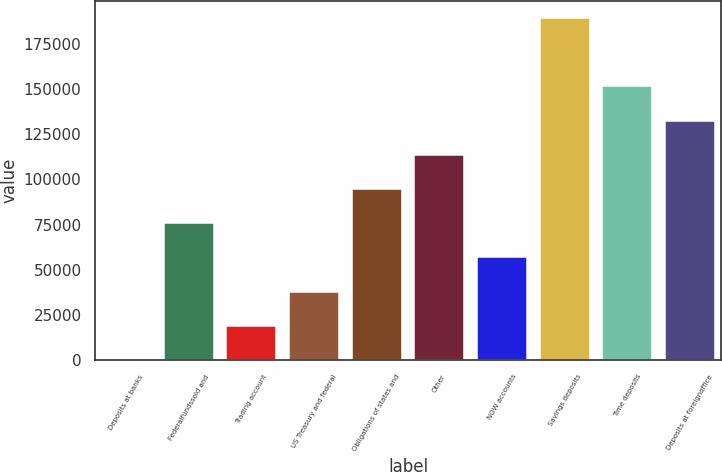Convert chart to OTSL. <chart><loc_0><loc_0><loc_500><loc_500><bar_chart><fcel>Deposits at banks<fcel>Federalfundssold and<fcel>Trading account<fcel>US Treasury and federal<fcel>Obligations of states and<fcel>Other<fcel>NOW accounts<fcel>Savings deposits<fcel>Time deposits<fcel>Deposits at foreignoffice<nl><fcel>75<fcel>75757.8<fcel>18995.7<fcel>37916.4<fcel>94678.5<fcel>113599<fcel>56837.1<fcel>189282<fcel>151441<fcel>132520<nl></chart> 